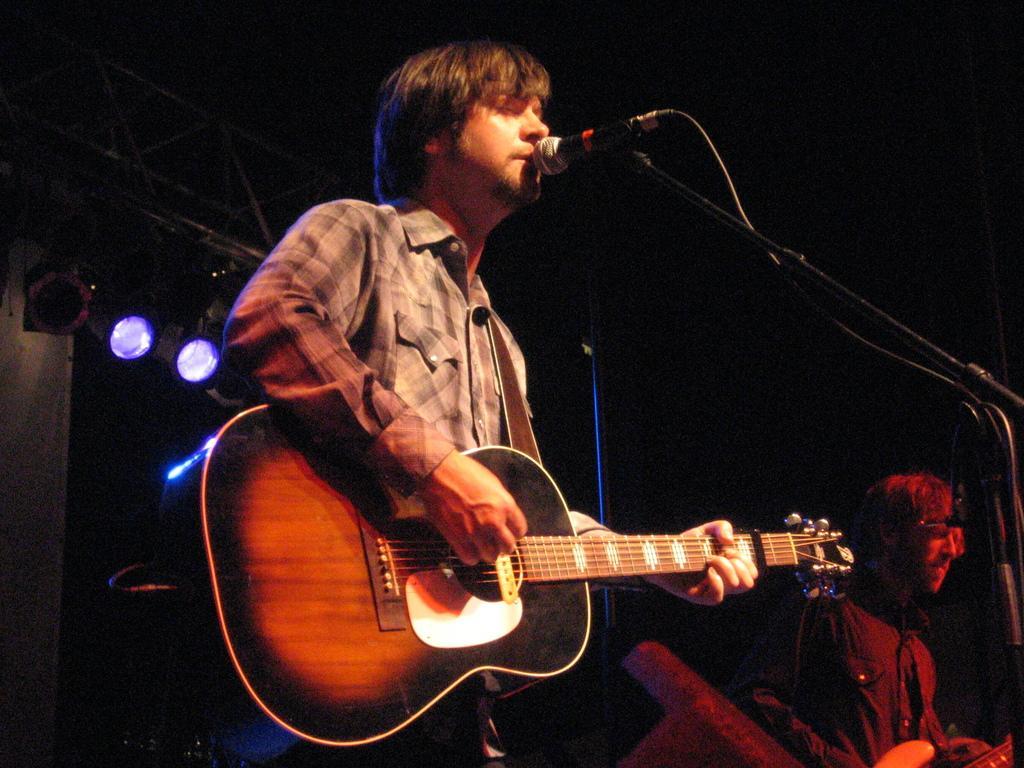Please provide a concise description of this image. There is a man who is singing on the mike and he is playing guitar. Here we can see a man. On the background there are lights. 